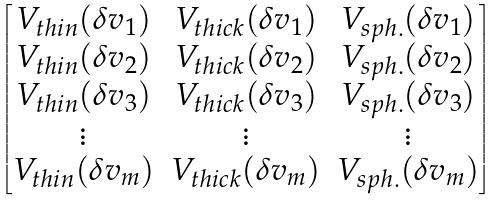Convert formula to latex. <formula><loc_0><loc_0><loc_500><loc_500>\begin{bmatrix} V _ { t h i n } ( \delta v _ { 1 } ) & V _ { t h i c k } ( \delta v _ { 1 } ) & V _ { s p h . } ( \delta v _ { 1 } ) \\ V _ { t h i n } ( \delta v _ { 2 } ) & V _ { t h i c k } ( \delta v _ { 2 } ) & V _ { s p h . } ( \delta v _ { 2 } ) \\ V _ { t h i n } ( \delta v _ { 3 } ) & V _ { t h i c k } ( \delta v _ { 3 } ) & V _ { s p h . } ( \delta v _ { 3 } ) \\ \vdots & \vdots & \vdots \\ V _ { t h i n } ( \delta v _ { m } ) & V _ { t h i c k } ( \delta v _ { m } ) & V _ { s p h . } ( \delta v _ { m } ) \\ \end{bmatrix}</formula> 